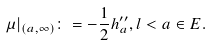Convert formula to latex. <formula><loc_0><loc_0><loc_500><loc_500>\mu | _ { ( a , \infty ) } \colon = - \frac { 1 } { 2 } h ^ { \prime \prime } _ { a } , l < a \in E .</formula> 